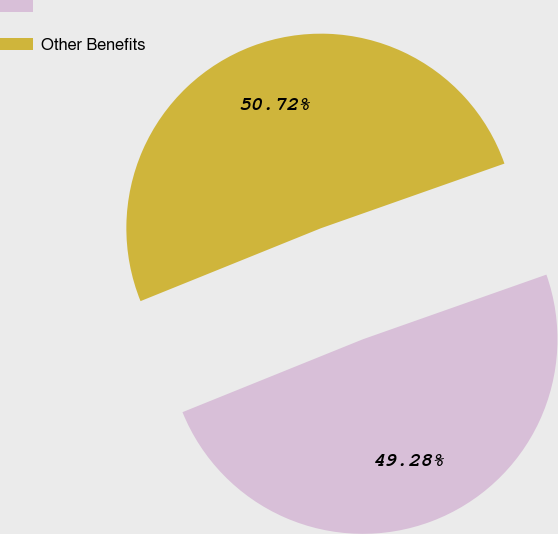Convert chart to OTSL. <chart><loc_0><loc_0><loc_500><loc_500><pie_chart><ecel><fcel>Other Benefits<nl><fcel>49.28%<fcel>50.72%<nl></chart> 